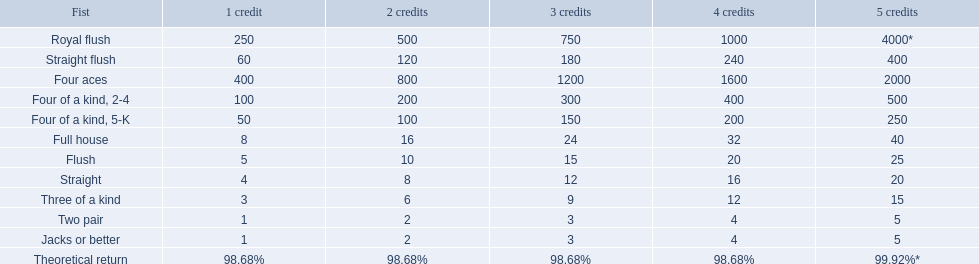What are the top 5 best types of hand for winning? Royal flush, Straight flush, Four aces, Four of a kind, 2-4, Four of a kind, 5-K. Between those 5, which of those hands are four of a kind? Four of a kind, 2-4, Four of a kind, 5-K. Of those 2 hands, which is the best kind of four of a kind for winning? Four of a kind, 2-4. 